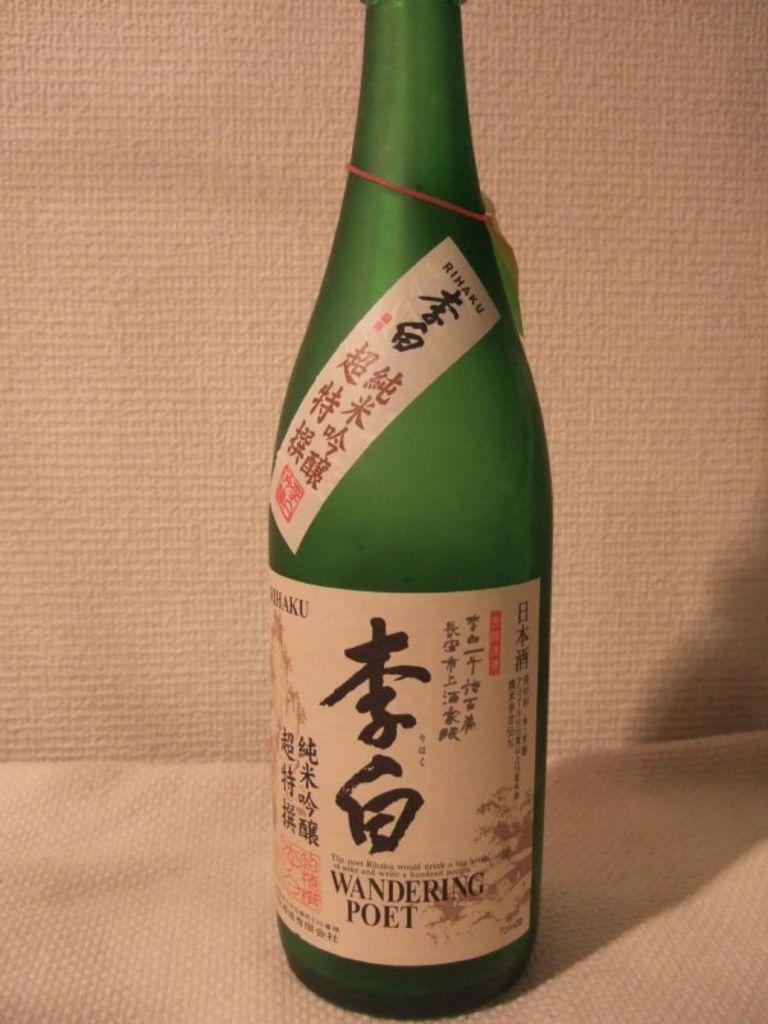What color is the bottle in the image? The bottle in the image is green. Are there any decorations or markings on the green bottle? Yes, the green bottle has stickers on it and a tag on it. What is the surface on which the green bottle is placed? The green bottle is placed on a white surface. What color is the background of the image? The background of the image is white. Who is the expert in the image providing advice about the engine? There is no expert or engine present in the image; it only features a green bottle with stickers and a tag on it. 